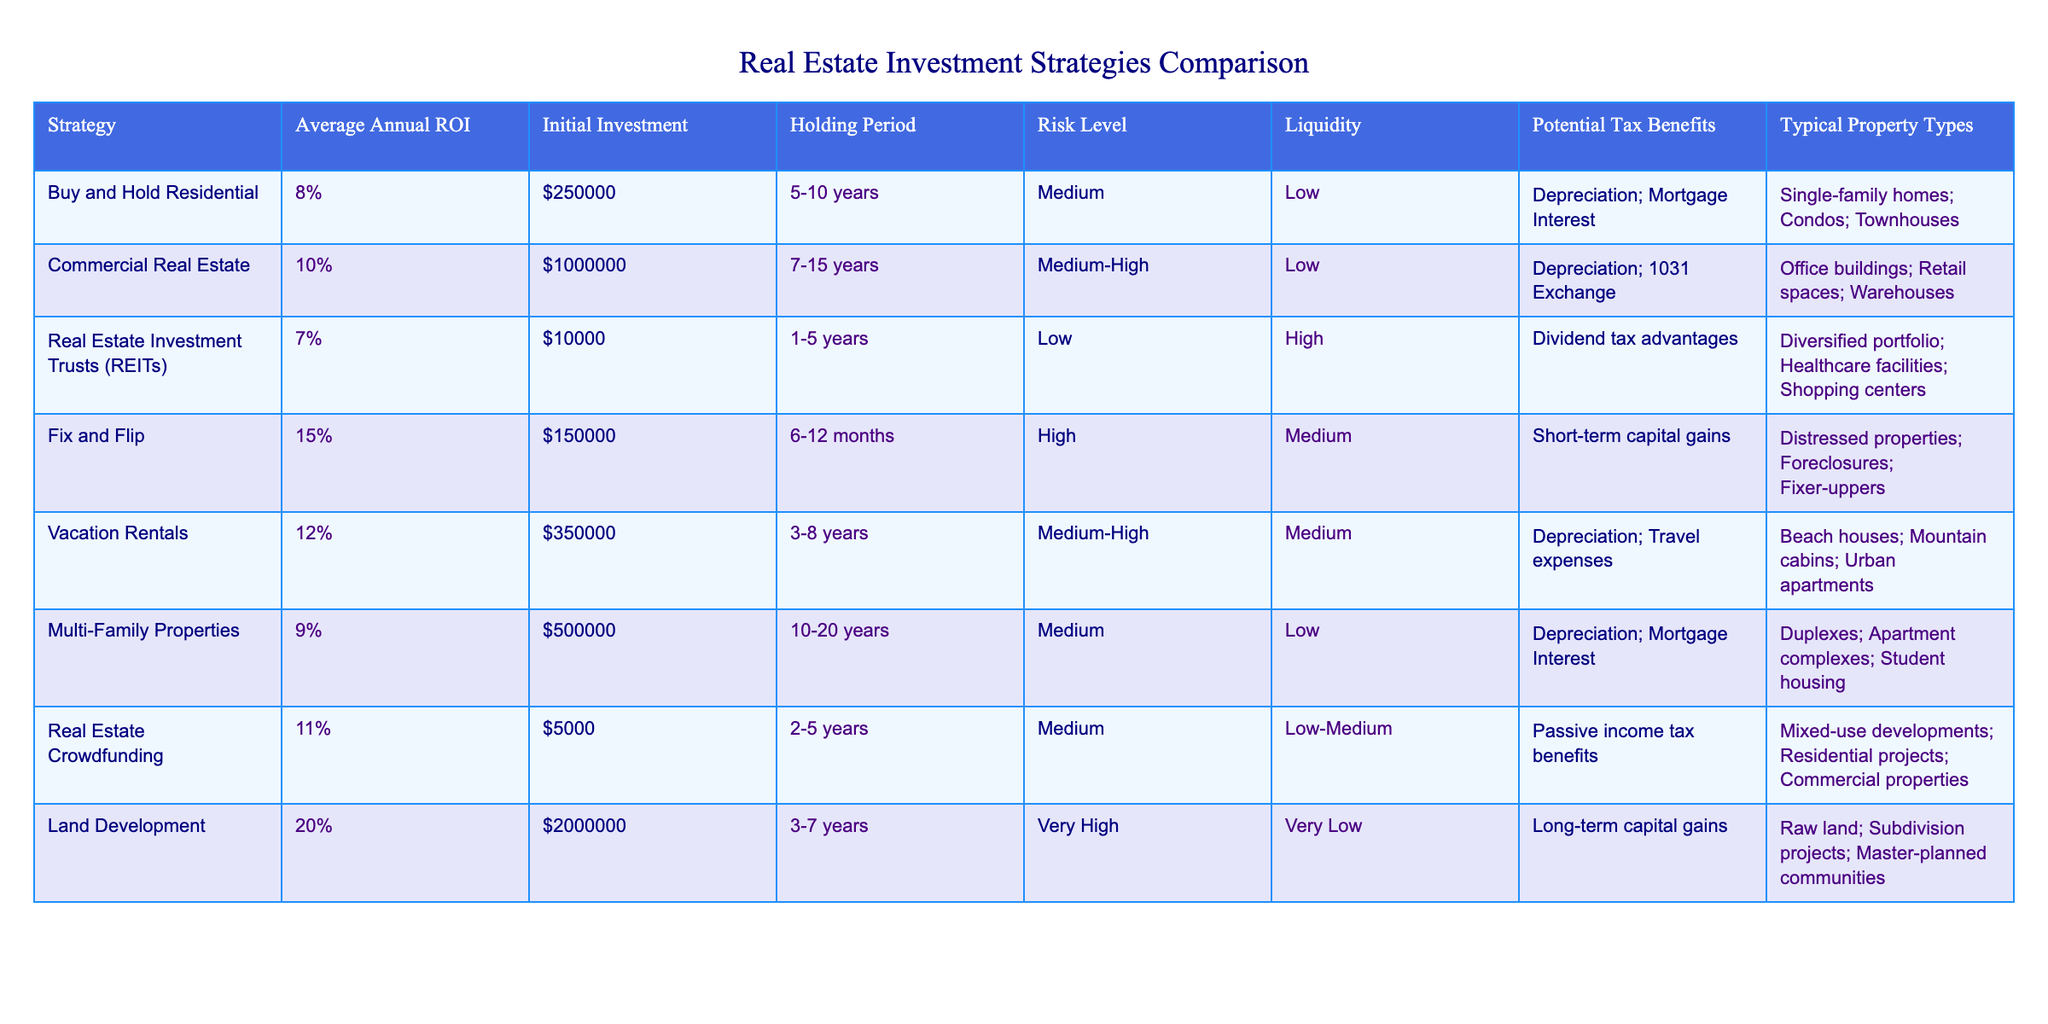What is the average annual ROI for the "Fix and Flip" strategy? The table shows that the "Fix and Flip" strategy has an Average Annual ROI of 15%.
Answer: 15% Which strategy has the highest initial investment requirement? From the table, "Commercial Real Estate" requires the highest initial investment of $1,000,000.
Answer: $1,000,000 True or False: Vacation Rentals have a higher average annual ROI than Real Estate Investment Trusts (REITs). The table shows that "Vacation Rentals" have an average annual ROI of 12%, while "REITs" have an ROI of 7%. Therefore, it is true that Vacation Rentals have a higher ROI than REITs.
Answer: True What is the risk level associated with Multi-Family Properties? According to the table, the risk level for Multi-Family Properties is classified as Medium.
Answer: Medium If you compare "Land Development" and "Fix and Flip," what is the difference in their average annual ROI? The average annual ROI for "Land Development" is 20% and for "Fix and Flip" is 15%. The difference is 20% - 15% = 5%.
Answer: 5% In terms of liquidity, which strategy offers the highest level? The table indicates that "Real Estate Investment Trusts (REITs)" have a High liquidity level compared to other strategies listed.
Answer: High What is the typical holding period for Commercial Real Estate investments? The "Commercial Real Estate" strategy has a holding period of 7-15 years as per the table.
Answer: 7-15 years Which strategy has potential tax benefits from short-term capital gains? The "Fix and Flip" strategy is noted for having potential tax benefits related to short-term capital gains in the table.
Answer: Fix and Flip Calculate the average initial investment for the Buy and Hold Residential and Multi-Family Properties strategies. The initial investment for "Buy and Hold Residential" is $250,000 and for "Multi-Family Properties" it is $500,000. Adding them gives $250,000 + $500,000 = $750,000, and dividing by 2 gives an average of $375,000.
Answer: $375,000 